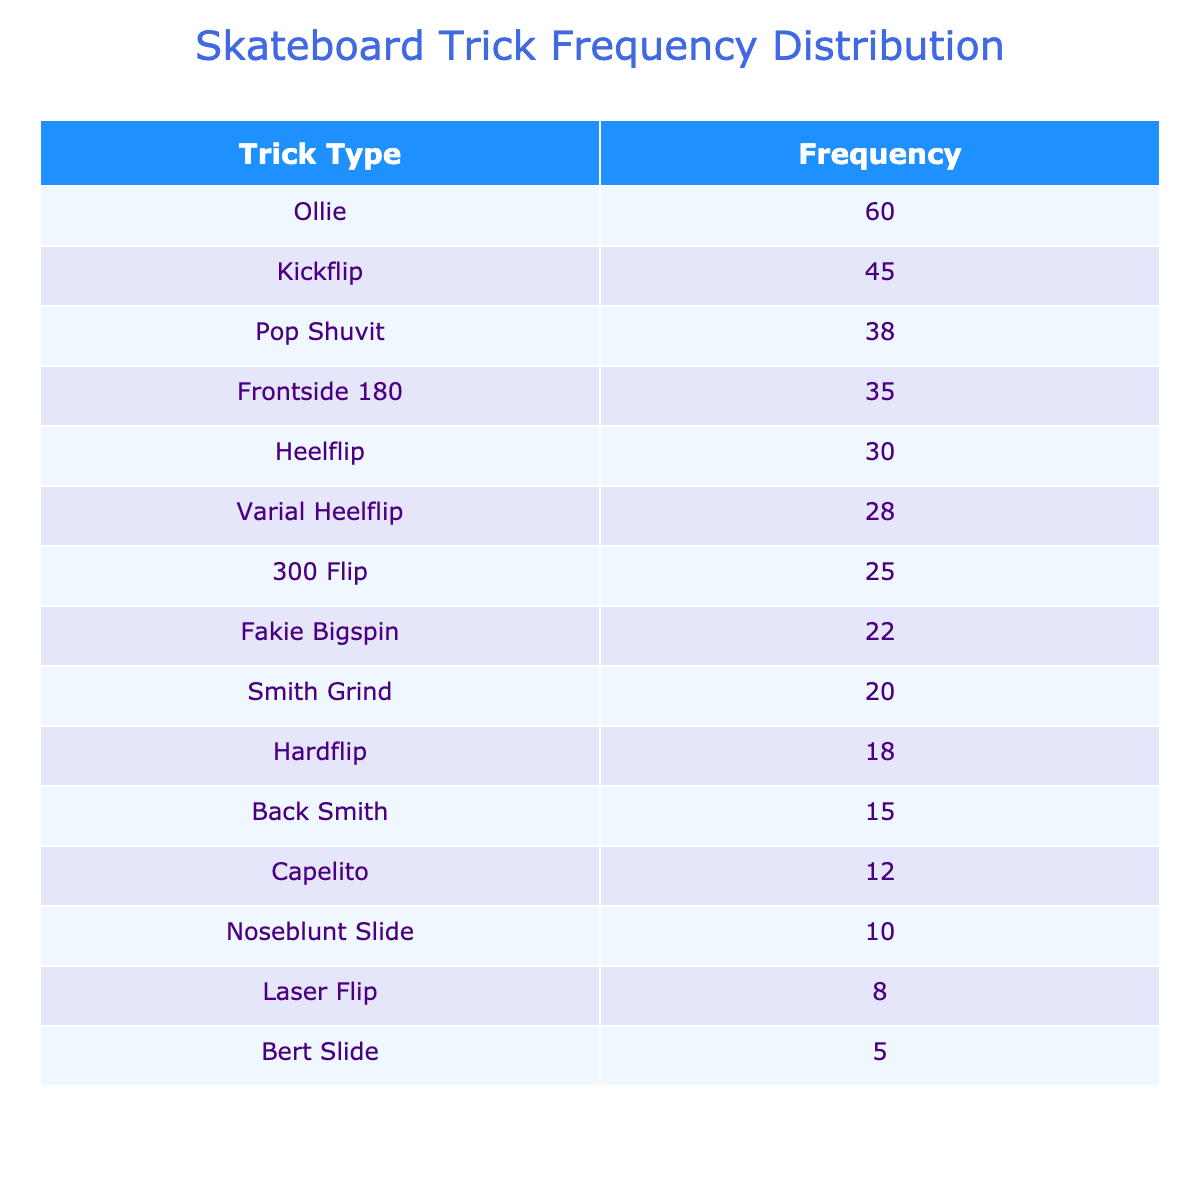What is the trick with the highest frequency? By examining the frequency column, we find that the Ollie trick has the highest frequency of 60.
Answer: Ollie How many Heelflips were performed? The table indicates that there were 30 Heelflips performed in total.
Answer: 30 What is the combined frequency of Capelito and Laser Flip? The frequency for Capelito is 12 and for Laser Flip is 8. Adding these together gives 12 + 8 = 20.
Answer: 20 Is the frequency of Hardflip greater than that of Back Smith? The frequency of Hardflip is 18, while Back Smith has a frequency of 15. Since 18 is greater than 15, the answer is yes.
Answer: Yes How many more Kickflips were performed than Smith Grinds? The frequency of Kickflips is 45 and Smith Grinds is 20. Subtracting these gives 45 - 20 = 25 more Kickflips.
Answer: 25 What is the average frequency of all the tricks listed? To find the average, sum all the frequencies: 45 + 30 + 60 + 25 + 20 + 15 + 10 + 35 + 38 + 22 + 18 + 28 + 12 + 8 + 5 =  378. There are 15 tricks, so the average is 378 / 15 = 25.2.
Answer: 25.2 Which trick types have a frequency below 15? The tricks with frequencies below 15 are Noseblunt Slide (10), Back Smith (15), and Bert Slide (5). Only Bert Slide is below 15, making the total count 1.
Answer: Bert Slide What is the frequency difference between Pop Shuvit and Fakie Bigspin? Pop Shuvit has a frequency of 38 and Fakie Bigspin has 22. The difference is 38 - 22 = 16.
Answer: 16 Which two tricks have the closest frequencies? The frequencies close to each other are Hardflip (18) and Back Smith (15). The difference between them is 3, which is the least among the pairs compared.
Answer: Hardflip and Back Smith 